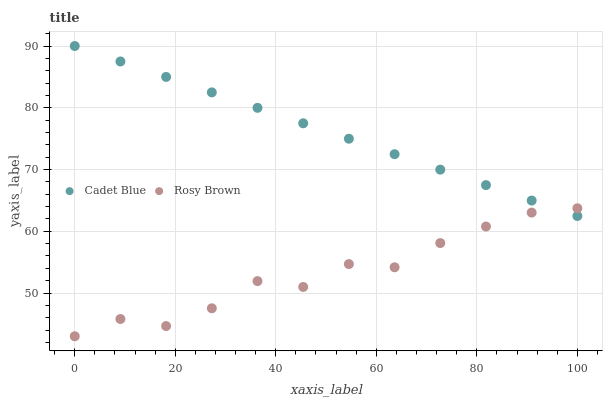Does Rosy Brown have the minimum area under the curve?
Answer yes or no. Yes. Does Cadet Blue have the maximum area under the curve?
Answer yes or no. Yes. Does Cadet Blue have the minimum area under the curve?
Answer yes or no. No. Is Cadet Blue the smoothest?
Answer yes or no. Yes. Is Rosy Brown the roughest?
Answer yes or no. Yes. Is Cadet Blue the roughest?
Answer yes or no. No. Does Rosy Brown have the lowest value?
Answer yes or no. Yes. Does Cadet Blue have the lowest value?
Answer yes or no. No. Does Cadet Blue have the highest value?
Answer yes or no. Yes. Does Rosy Brown intersect Cadet Blue?
Answer yes or no. Yes. Is Rosy Brown less than Cadet Blue?
Answer yes or no. No. Is Rosy Brown greater than Cadet Blue?
Answer yes or no. No. 